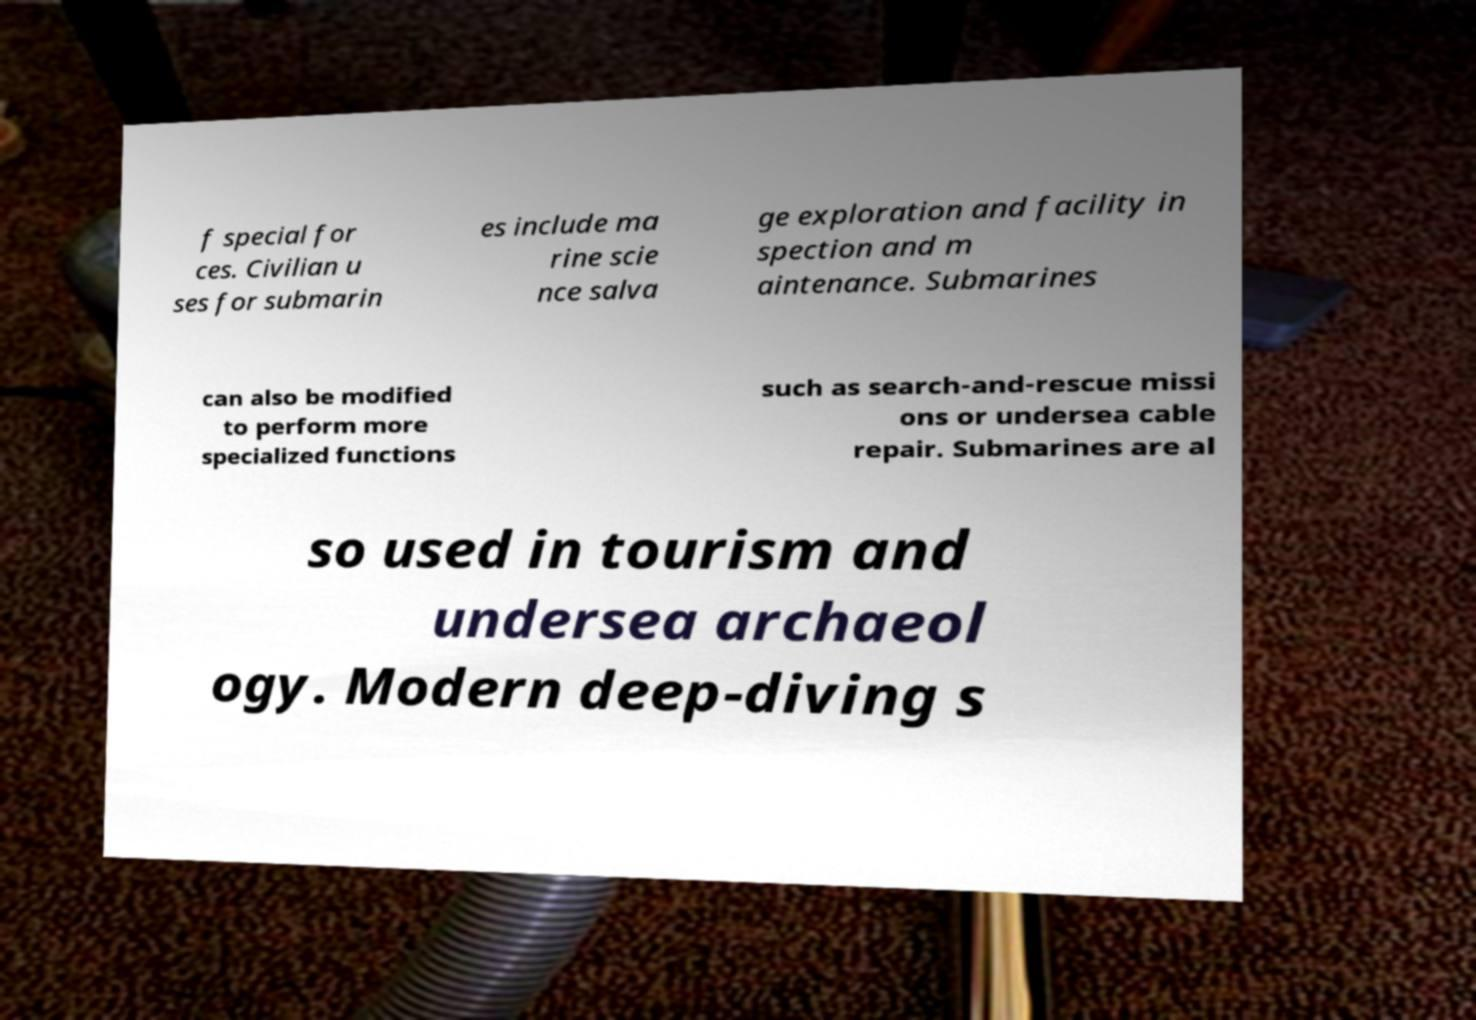Please identify and transcribe the text found in this image. f special for ces. Civilian u ses for submarin es include ma rine scie nce salva ge exploration and facility in spection and m aintenance. Submarines can also be modified to perform more specialized functions such as search-and-rescue missi ons or undersea cable repair. Submarines are al so used in tourism and undersea archaeol ogy. Modern deep-diving s 